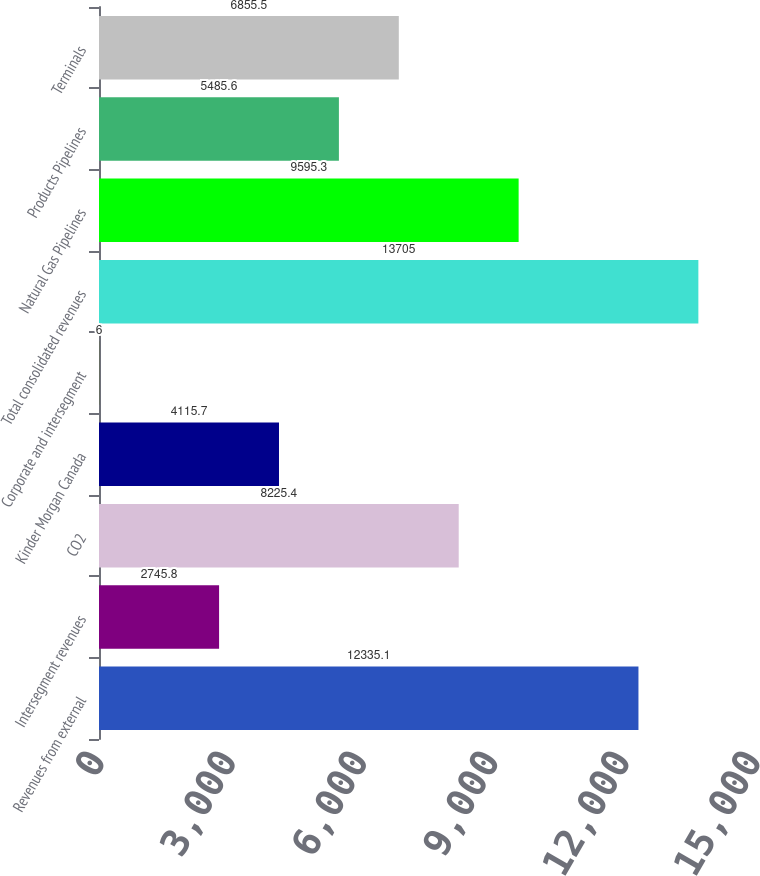Convert chart to OTSL. <chart><loc_0><loc_0><loc_500><loc_500><bar_chart><fcel>Revenues from external<fcel>Intersegment revenues<fcel>CO2<fcel>Kinder Morgan Canada<fcel>Corporate and intersegment<fcel>Total consolidated revenues<fcel>Natural Gas Pipelines<fcel>Products Pipelines<fcel>Terminals<nl><fcel>12335.1<fcel>2745.8<fcel>8225.4<fcel>4115.7<fcel>6<fcel>13705<fcel>9595.3<fcel>5485.6<fcel>6855.5<nl></chart> 